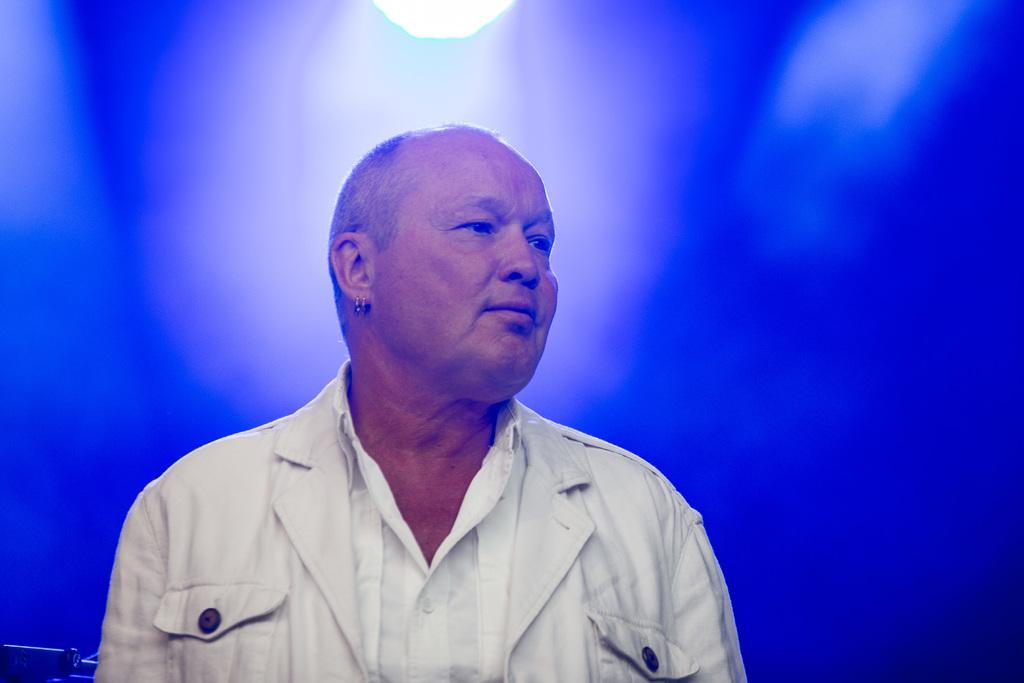Who or what is present in the image? There is a person in the image. What is the person wearing? The person is wearing a white dress. What color is the background of the image? The background of the image is blue. What type of system is being used by the person in the image? There is no system visible in the image; it only shows a person wearing a white dress against a blue background. 